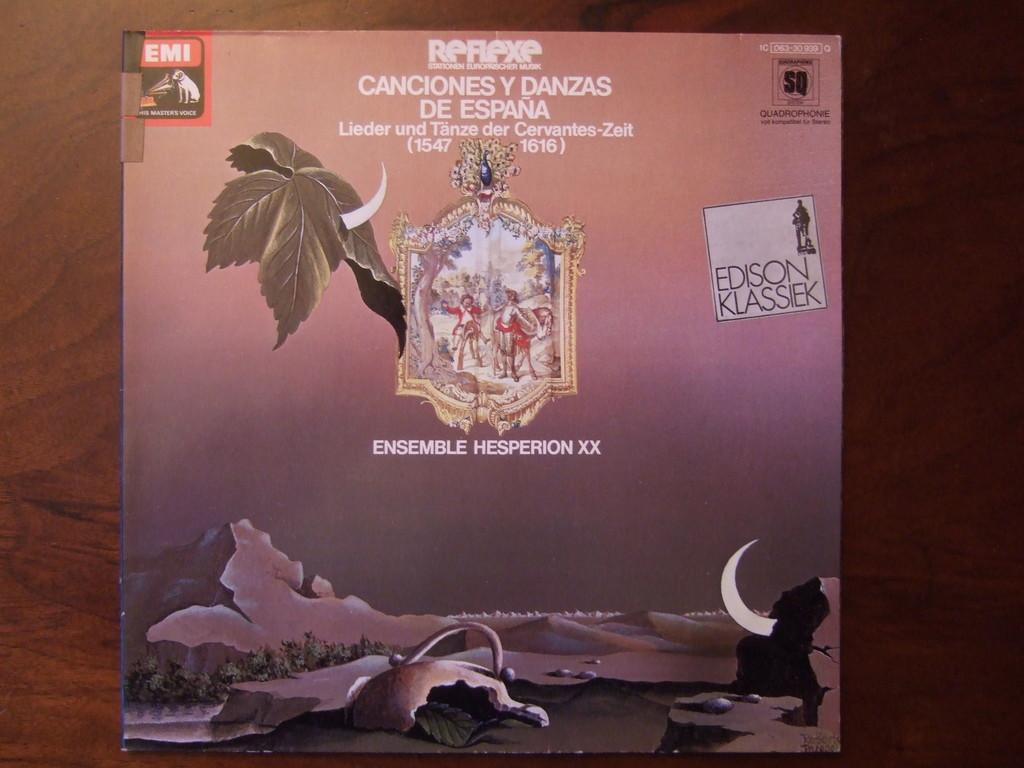What is the color of the surface in the image? The surface in the image is brown colored. What object can be seen on the brown surface? There is a book on the brown surface. What type of paper is being traded on the brown surface in the image? There is no paper or trade activity depicted in the image; it only shows a book on a brown surface. 